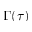<formula> <loc_0><loc_0><loc_500><loc_500>\Gamma ( \tau )</formula> 